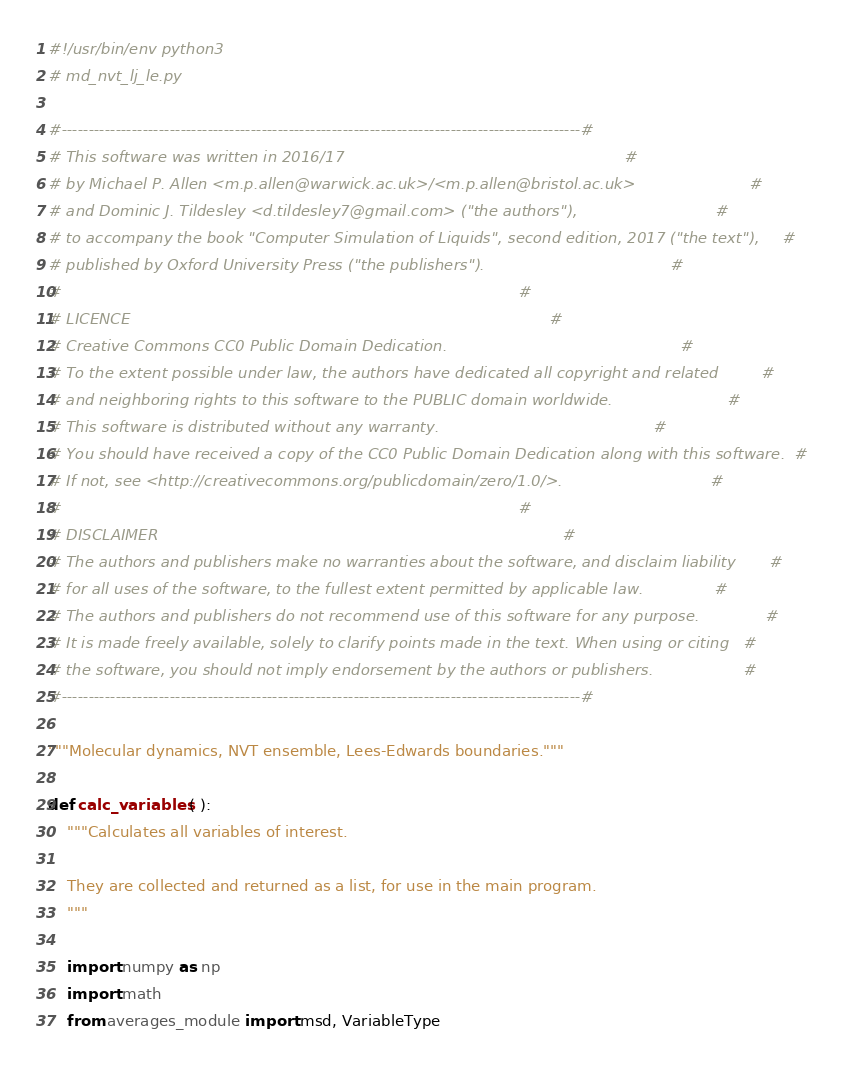Convert code to text. <code><loc_0><loc_0><loc_500><loc_500><_Python_>#!/usr/bin/env python3
# md_nvt_lj_le.py

#------------------------------------------------------------------------------------------------#
# This software was written in 2016/17                                                           #
# by Michael P. Allen <m.p.allen@warwick.ac.uk>/<m.p.allen@bristol.ac.uk>                        #
# and Dominic J. Tildesley <d.tildesley7@gmail.com> ("the authors"),                             #
# to accompany the book "Computer Simulation of Liquids", second edition, 2017 ("the text"),     #
# published by Oxford University Press ("the publishers").                                       #
#                                                                                                #
# LICENCE                                                                                        #
# Creative Commons CC0 Public Domain Dedication.                                                 #
# To the extent possible under law, the authors have dedicated all copyright and related         #
# and neighboring rights to this software to the PUBLIC domain worldwide.                        #
# This software is distributed without any warranty.                                             #
# You should have received a copy of the CC0 Public Domain Dedication along with this software.  #
# If not, see <http://creativecommons.org/publicdomain/zero/1.0/>.                               #
#                                                                                                #
# DISCLAIMER                                                                                     #
# The authors and publishers make no warranties about the software, and disclaim liability       #
# for all uses of the software, to the fullest extent permitted by applicable law.               #
# The authors and publishers do not recommend use of this software for any purpose.              #
# It is made freely available, solely to clarify points made in the text. When using or citing   #
# the software, you should not imply endorsement by the authors or publishers.                   #
#------------------------------------------------------------------------------------------------#

"""Molecular dynamics, NVT ensemble, Lees-Edwards boundaries."""

def calc_variables ( ):
    """Calculates all variables of interest.
    
    They are collected and returned as a list, for use in the main program.
    """

    import numpy as np
    import math
    from averages_module import msd, VariableType
</code> 